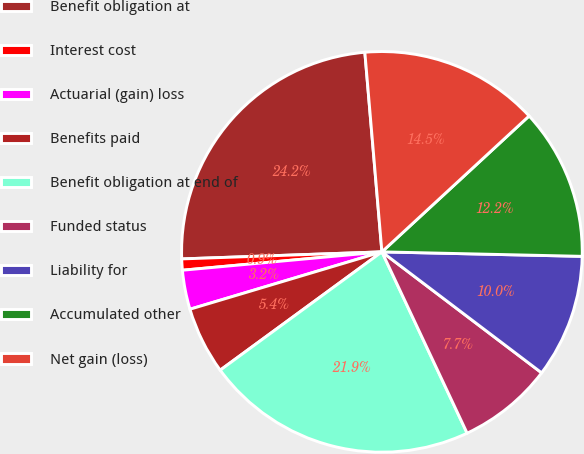Convert chart. <chart><loc_0><loc_0><loc_500><loc_500><pie_chart><fcel>Benefit obligation at<fcel>Interest cost<fcel>Actuarial (gain) loss<fcel>Benefits paid<fcel>Benefit obligation at end of<fcel>Funded status<fcel>Liability for<fcel>Accumulated other<fcel>Net gain (loss)<nl><fcel>24.2%<fcel>0.9%<fcel>3.16%<fcel>5.43%<fcel>21.94%<fcel>7.69%<fcel>9.96%<fcel>12.22%<fcel>14.49%<nl></chart> 